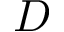Convert formula to latex. <formula><loc_0><loc_0><loc_500><loc_500>D</formula> 